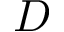Convert formula to latex. <formula><loc_0><loc_0><loc_500><loc_500>D</formula> 